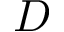Convert formula to latex. <formula><loc_0><loc_0><loc_500><loc_500>D</formula> 